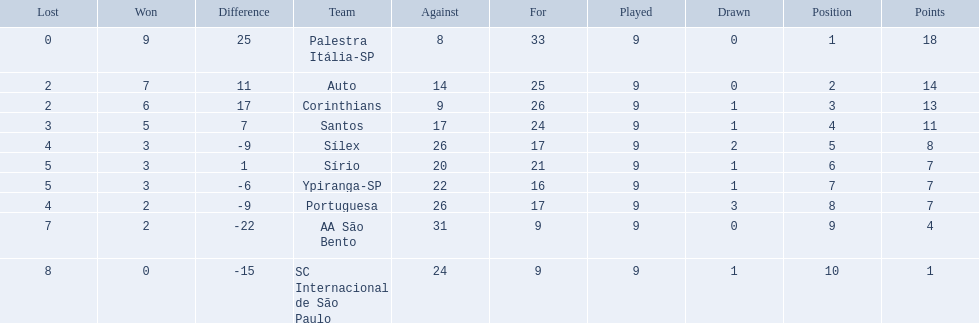What were all the teams that competed in 1926 brazilian football? Palestra Itália-SP, Auto, Corinthians, Santos, Sílex, Sírio, Ypiranga-SP, Portuguesa, AA São Bento, SC Internacional de São Paulo. Parse the full table. {'header': ['Lost', 'Won', 'Difference', 'Team', 'Against', 'For', 'Played', 'Drawn', 'Position', 'Points'], 'rows': [['0', '9', '25', 'Palestra Itália-SP', '8', '33', '9', '0', '1', '18'], ['2', '7', '11', 'Auto', '14', '25', '9', '0', '2', '14'], ['2', '6', '17', 'Corinthians', '9', '26', '9', '1', '3', '13'], ['3', '5', '7', 'Santos', '17', '24', '9', '1', '4', '11'], ['4', '3', '-9', 'Sílex', '26', '17', '9', '2', '5', '8'], ['5', '3', '1', 'Sírio', '20', '21', '9', '1', '6', '7'], ['5', '3', '-6', 'Ypiranga-SP', '22', '16', '9', '1', '7', '7'], ['4', '2', '-9', 'Portuguesa', '26', '17', '9', '3', '8', '7'], ['7', '2', '-22', 'AA São Bento', '31', '9', '9', '0', '9', '4'], ['8', '0', '-15', 'SC Internacional de São Paulo', '24', '9', '9', '1', '10', '1']]} Which of these had zero games lost? Palestra Itália-SP. 